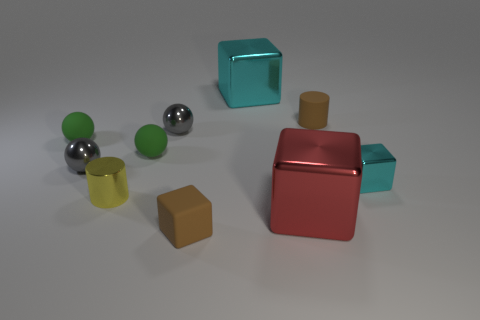There is a matte thing that is the same color as the rubber block; what shape is it?
Ensure brevity in your answer.  Cylinder. There is another thing that is the same shape as the yellow metal thing; what is it made of?
Provide a succinct answer. Rubber. What is the size of the cyan object that is behind the cyan shiny object to the right of the big thing in front of the tiny yellow object?
Your response must be concise. Large. Do the rubber cube and the metal cylinder have the same size?
Your answer should be compact. Yes. The brown cube that is on the left side of the small brown matte object behind the small cyan metal thing is made of what material?
Provide a succinct answer. Rubber. There is a small metal object that is on the right side of the brown cube; does it have the same shape as the brown rubber object in front of the large red metal object?
Your answer should be compact. Yes. Is the number of brown matte cylinders that are behind the large cyan object the same as the number of red shiny cubes?
Your response must be concise. No. There is a brown matte thing to the left of the large cyan object; are there any brown cylinders behind it?
Your answer should be compact. Yes. Is there anything else that is the same color as the small metallic cube?
Your response must be concise. Yes. Are the big block that is in front of the large cyan object and the brown cube made of the same material?
Provide a succinct answer. No. 